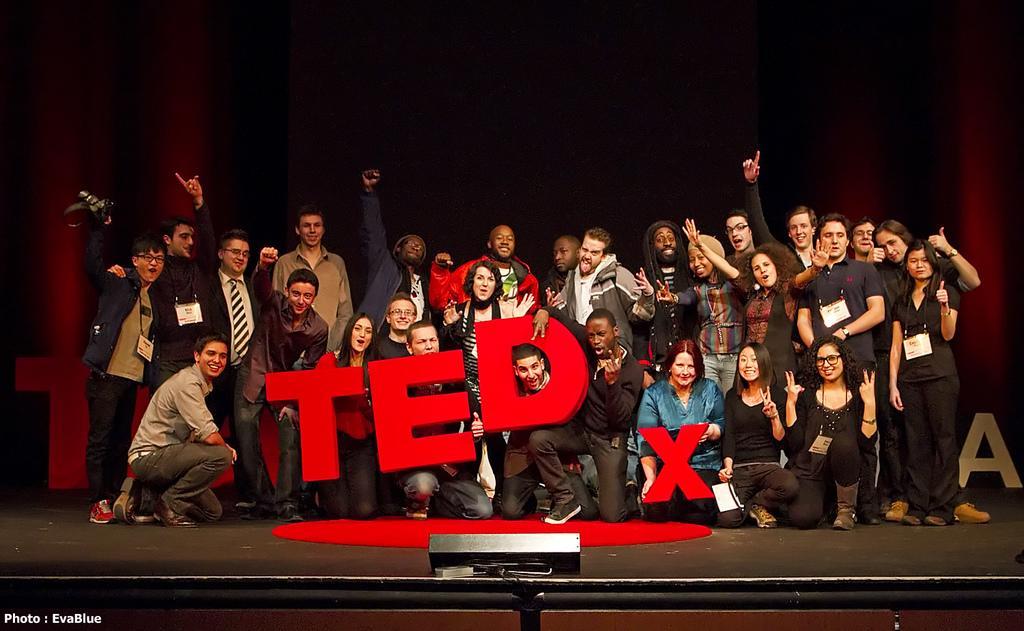How would you summarize this image in a sentence or two? This image consists of many people on the dais. They are holding TEDx in their hands. At the bottom, there is a dais. In the background, there are curtains. 